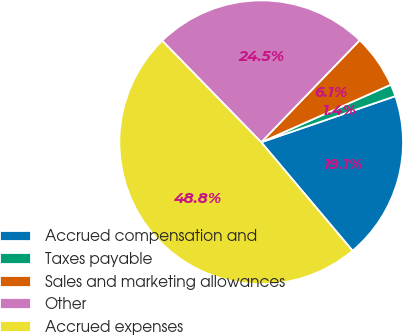<chart> <loc_0><loc_0><loc_500><loc_500><pie_chart><fcel>Accrued compensation and<fcel>Taxes payable<fcel>Sales and marketing allowances<fcel>Other<fcel>Accrued expenses<nl><fcel>19.13%<fcel>1.38%<fcel>6.13%<fcel>24.52%<fcel>48.84%<nl></chart> 